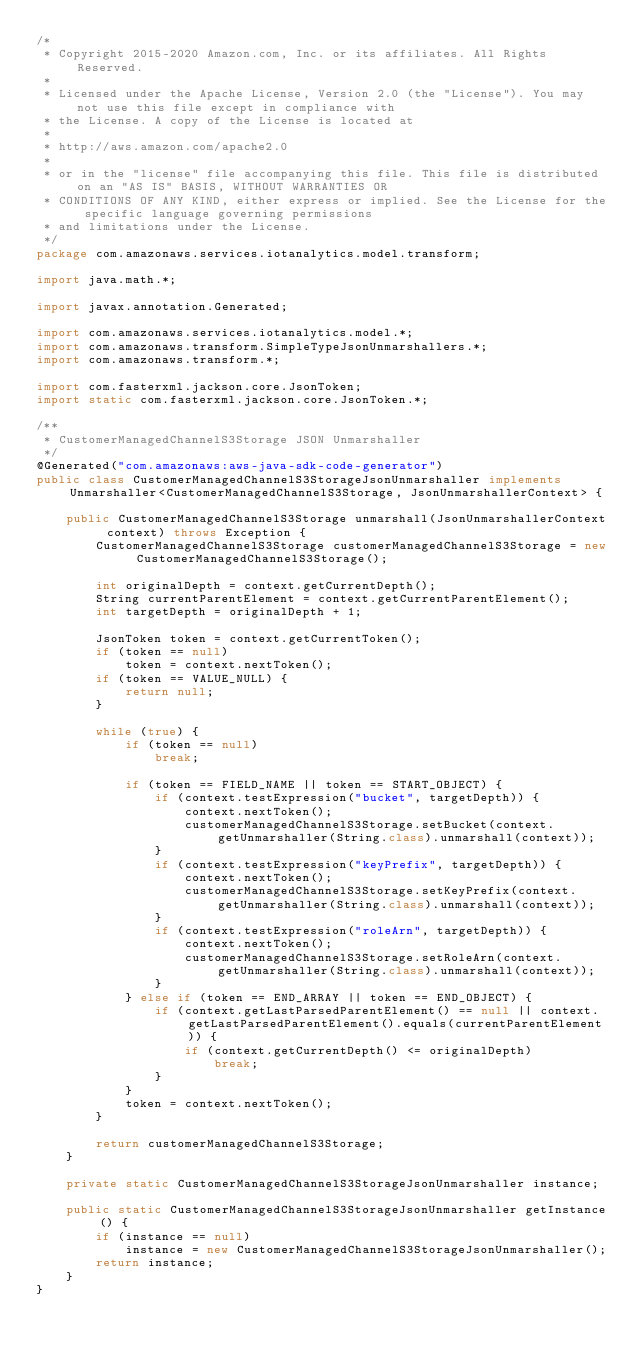Convert code to text. <code><loc_0><loc_0><loc_500><loc_500><_Java_>/*
 * Copyright 2015-2020 Amazon.com, Inc. or its affiliates. All Rights Reserved.
 * 
 * Licensed under the Apache License, Version 2.0 (the "License"). You may not use this file except in compliance with
 * the License. A copy of the License is located at
 * 
 * http://aws.amazon.com/apache2.0
 * 
 * or in the "license" file accompanying this file. This file is distributed on an "AS IS" BASIS, WITHOUT WARRANTIES OR
 * CONDITIONS OF ANY KIND, either express or implied. See the License for the specific language governing permissions
 * and limitations under the License.
 */
package com.amazonaws.services.iotanalytics.model.transform;

import java.math.*;

import javax.annotation.Generated;

import com.amazonaws.services.iotanalytics.model.*;
import com.amazonaws.transform.SimpleTypeJsonUnmarshallers.*;
import com.amazonaws.transform.*;

import com.fasterxml.jackson.core.JsonToken;
import static com.fasterxml.jackson.core.JsonToken.*;

/**
 * CustomerManagedChannelS3Storage JSON Unmarshaller
 */
@Generated("com.amazonaws:aws-java-sdk-code-generator")
public class CustomerManagedChannelS3StorageJsonUnmarshaller implements Unmarshaller<CustomerManagedChannelS3Storage, JsonUnmarshallerContext> {

    public CustomerManagedChannelS3Storage unmarshall(JsonUnmarshallerContext context) throws Exception {
        CustomerManagedChannelS3Storage customerManagedChannelS3Storage = new CustomerManagedChannelS3Storage();

        int originalDepth = context.getCurrentDepth();
        String currentParentElement = context.getCurrentParentElement();
        int targetDepth = originalDepth + 1;

        JsonToken token = context.getCurrentToken();
        if (token == null)
            token = context.nextToken();
        if (token == VALUE_NULL) {
            return null;
        }

        while (true) {
            if (token == null)
                break;

            if (token == FIELD_NAME || token == START_OBJECT) {
                if (context.testExpression("bucket", targetDepth)) {
                    context.nextToken();
                    customerManagedChannelS3Storage.setBucket(context.getUnmarshaller(String.class).unmarshall(context));
                }
                if (context.testExpression("keyPrefix", targetDepth)) {
                    context.nextToken();
                    customerManagedChannelS3Storage.setKeyPrefix(context.getUnmarshaller(String.class).unmarshall(context));
                }
                if (context.testExpression("roleArn", targetDepth)) {
                    context.nextToken();
                    customerManagedChannelS3Storage.setRoleArn(context.getUnmarshaller(String.class).unmarshall(context));
                }
            } else if (token == END_ARRAY || token == END_OBJECT) {
                if (context.getLastParsedParentElement() == null || context.getLastParsedParentElement().equals(currentParentElement)) {
                    if (context.getCurrentDepth() <= originalDepth)
                        break;
                }
            }
            token = context.nextToken();
        }

        return customerManagedChannelS3Storage;
    }

    private static CustomerManagedChannelS3StorageJsonUnmarshaller instance;

    public static CustomerManagedChannelS3StorageJsonUnmarshaller getInstance() {
        if (instance == null)
            instance = new CustomerManagedChannelS3StorageJsonUnmarshaller();
        return instance;
    }
}
</code> 